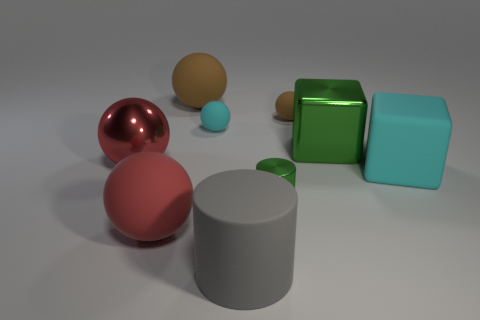Subtract all small brown matte balls. How many balls are left? 4 Subtract all purple balls. Subtract all green blocks. How many balls are left? 5 Add 1 large red matte balls. How many objects exist? 10 Subtract all cylinders. How many objects are left? 7 Subtract 0 cyan cylinders. How many objects are left? 9 Subtract all red rubber things. Subtract all red things. How many objects are left? 6 Add 8 cyan matte objects. How many cyan matte objects are left? 10 Add 7 big green metallic blocks. How many big green metallic blocks exist? 8 